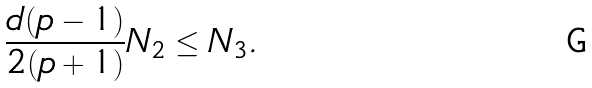Convert formula to latex. <formula><loc_0><loc_0><loc_500><loc_500>\frac { d ( p - 1 ) } { 2 ( p + 1 ) } N _ { 2 } \leq N _ { 3 } .</formula> 